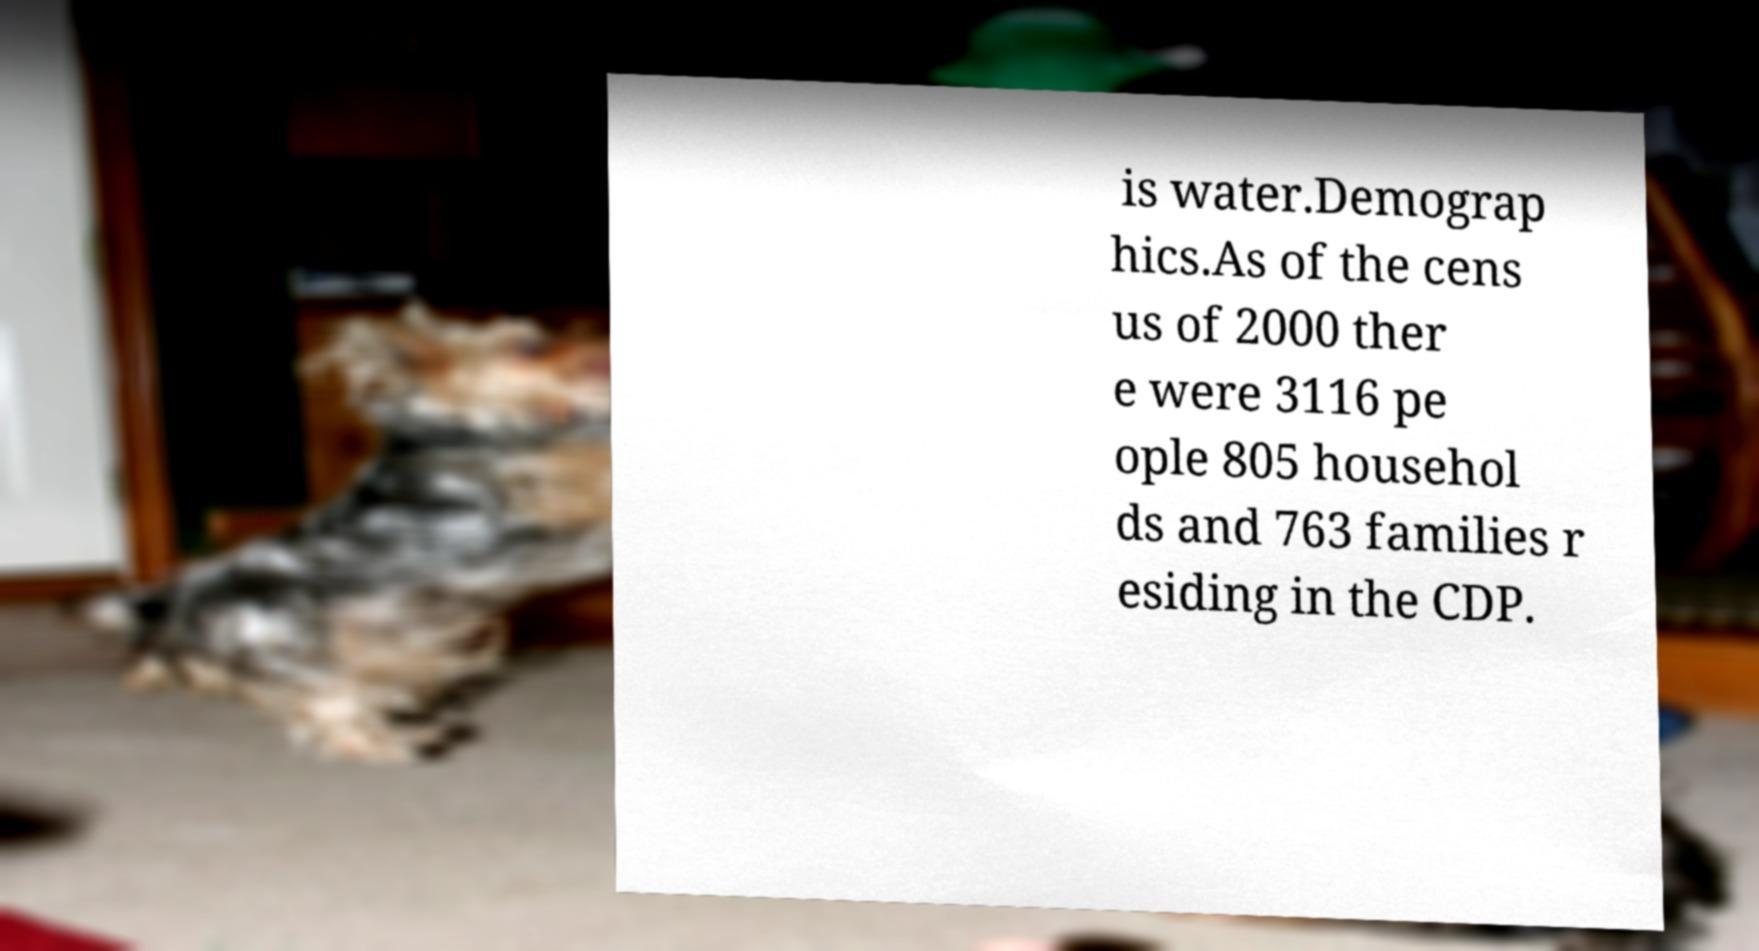For documentation purposes, I need the text within this image transcribed. Could you provide that? is water.Demograp hics.As of the cens us of 2000 ther e were 3116 pe ople 805 househol ds and 763 families r esiding in the CDP. 